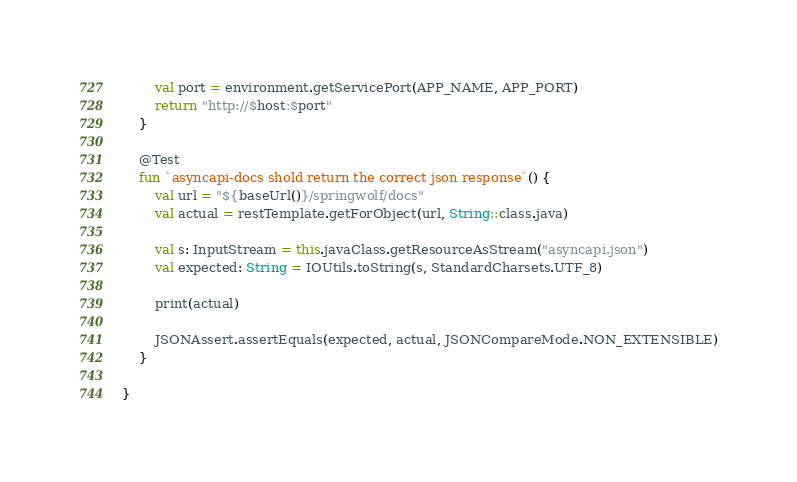Convert code to text. <code><loc_0><loc_0><loc_500><loc_500><_Kotlin_>        val port = environment.getServicePort(APP_NAME, APP_PORT)
        return "http://$host:$port"
    }

    @Test
    fun `asyncapi-docs shold return the correct json response`() {
        val url = "${baseUrl()}/springwolf/docs"
        val actual = restTemplate.getForObject(url, String::class.java)

        val s: InputStream = this.javaClass.getResourceAsStream("asyncapi.json")
        val expected: String = IOUtils.toString(s, StandardCharsets.UTF_8)

        print(actual)

        JSONAssert.assertEquals(expected, actual, JSONCompareMode.NON_EXTENSIBLE)
    }

}</code> 